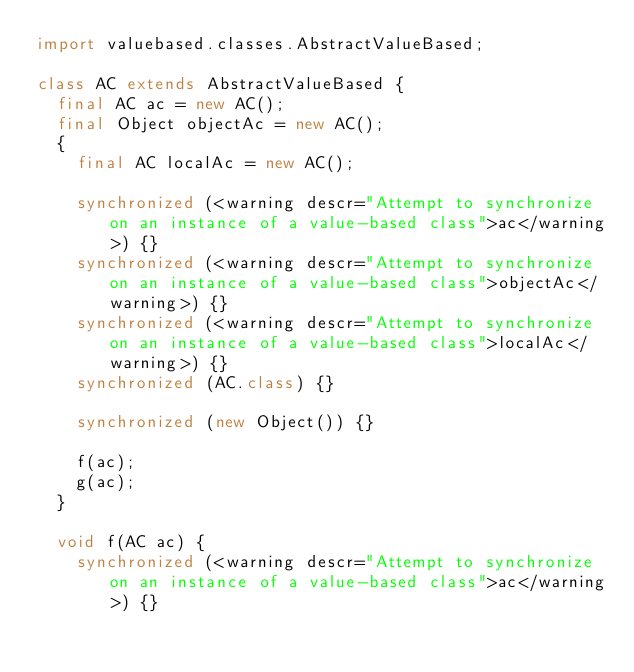<code> <loc_0><loc_0><loc_500><loc_500><_Java_>import valuebased.classes.AbstractValueBased;

class AC extends AbstractValueBased {
  final AC ac = new AC();
  final Object objectAc = new AC();
  {
    final AC localAc = new AC();

    synchronized (<warning descr="Attempt to synchronize on an instance of a value-based class">ac</warning>) {}
    synchronized (<warning descr="Attempt to synchronize on an instance of a value-based class">objectAc</warning>) {}
    synchronized (<warning descr="Attempt to synchronize on an instance of a value-based class">localAc</warning>) {}
    synchronized (AC.class) {}

    synchronized (new Object()) {}

    f(ac);
    g(ac);
  }

  void f(AC ac) {
    synchronized (<warning descr="Attempt to synchronize on an instance of a value-based class">ac</warning>) {}</code> 